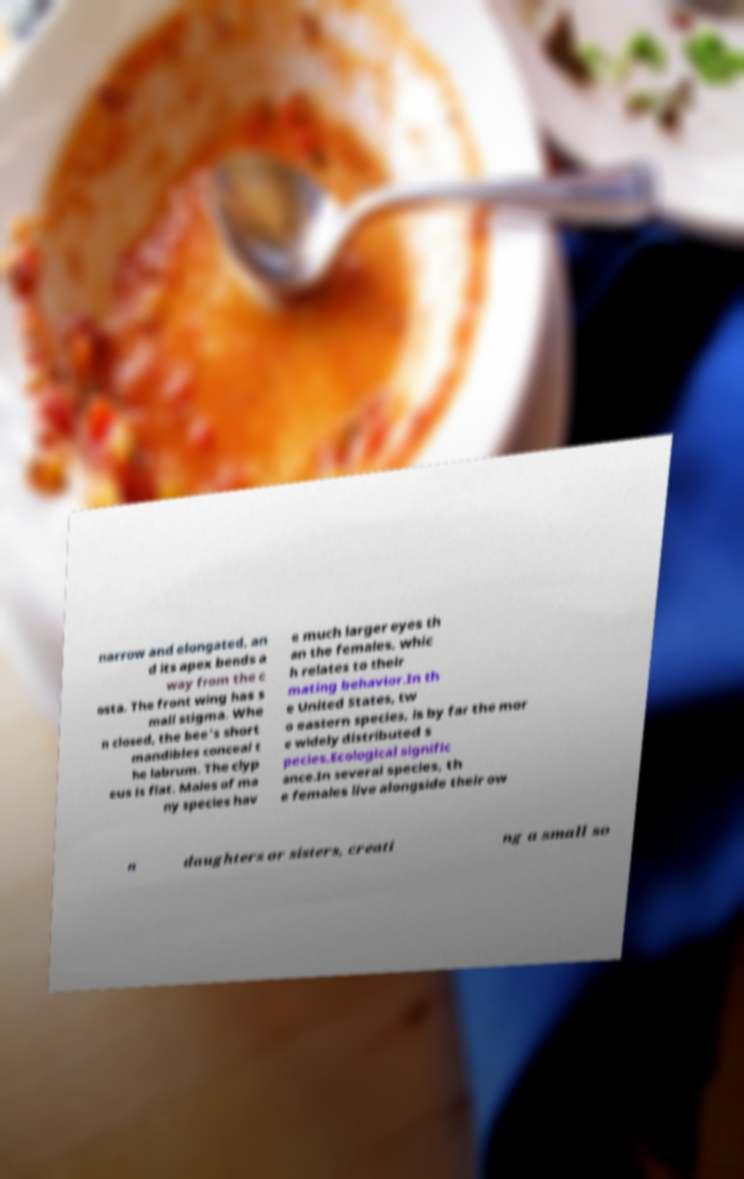Could you assist in decoding the text presented in this image and type it out clearly? narrow and elongated, an d its apex bends a way from the c osta. The front wing has s mall stigma. Whe n closed, the bee's short mandibles conceal t he labrum. The clyp eus is flat. Males of ma ny species hav e much larger eyes th an the females, whic h relates to their mating behavior.In th e United States, tw o eastern species, is by far the mor e widely distributed s pecies.Ecological signific ance.In several species, th e females live alongside their ow n daughters or sisters, creati ng a small so 